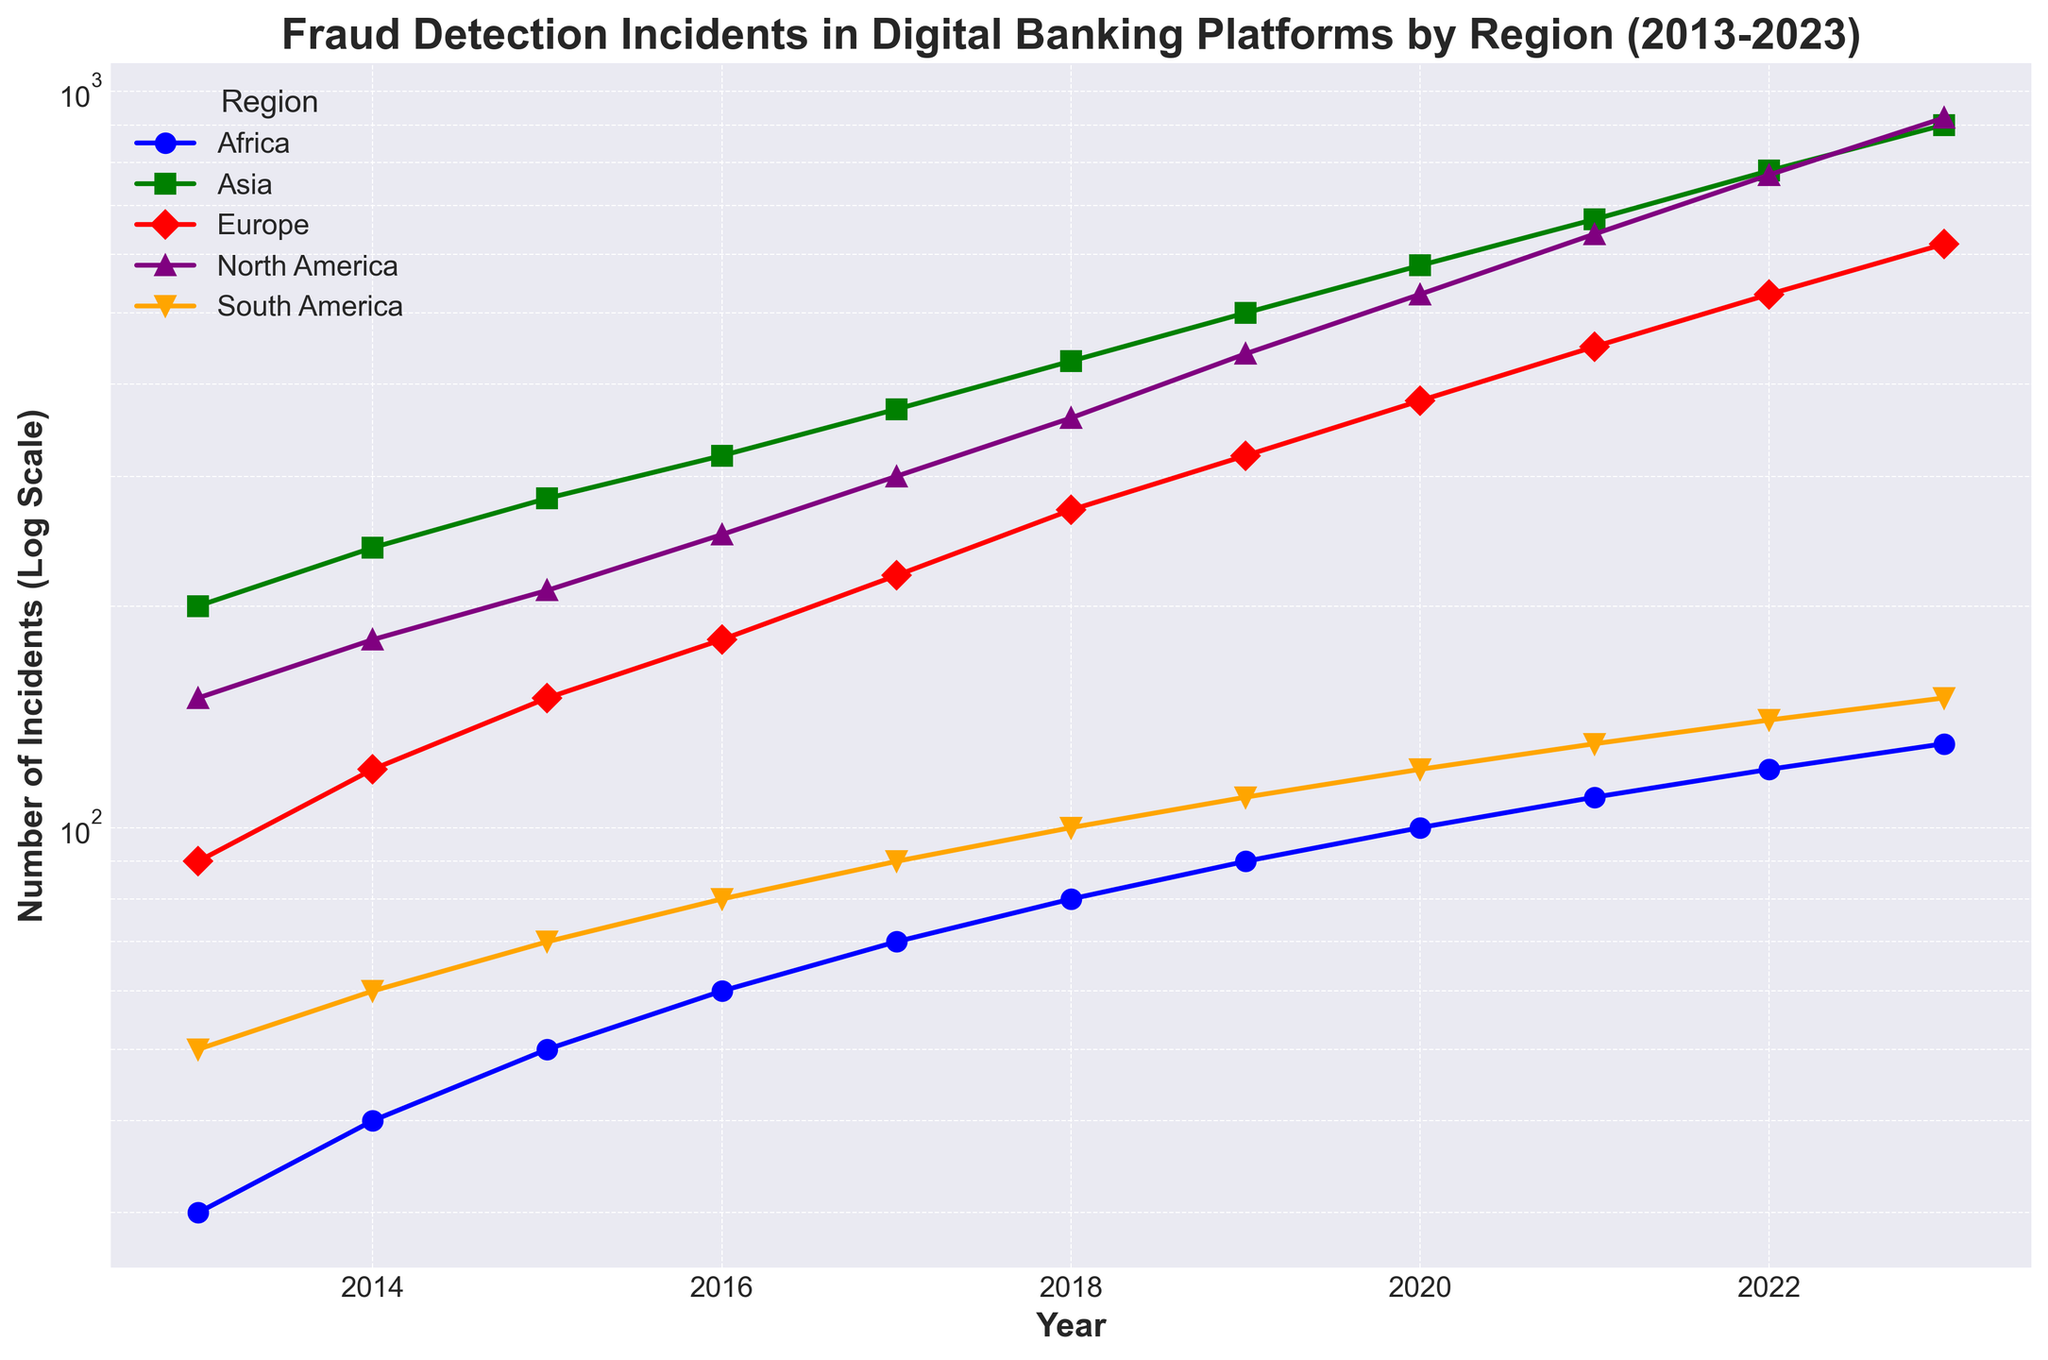Which region reported the highest number of fraud incidents in 2023? Look at the endpoints on the plot for 2023. Find the marker corresponding to each region and compare their values to determine the highest.
Answer: North America Which regions show an upward trend in fraud incidents over the last decade? Observe each region's line plot from 2013 to 2023. Identify which lines show a consistent increase over these years.
Answer: All regions Which year recorded the highest increase in fraud incidents in North America from the previous year? Look at North America's plot points year by year and calculate the difference between consecutive years to identify the biggest jump.
Answer: 2022 By how much did the fraud incidents in Asia increase from 2013 to 2023? Find the endpoints of Asia's plot for 2013 and 2023. Subtract the value of 2013 from 2023 to determine the increase.
Answer: 700 incidents In which year did South America have its first significant increase in fraud incidents? Look at South America's plot from 2013 onwards. Determine the first year when there's a noticeable rise compared to the previous year.
Answer: 2017 Which region had the least number of fraud incidents in 2013? Compare the markers for all regions in 2013 to find the lowest one.
Answer: Africa What is the trend in Europe’s fraud incidents from 2016 to 2019? Observe the plot for Europe from 2016 to 2019. Determine if the line is increasing, decreasing, or stable during these years.
Answer: Increasing Between 2015 and 2020, which region saw the highest percentage growth in fraud incidents? Calculate the percentage growth for each region using the formula \((\text{Incidents in 2020} - \text{Incidents in 2015}) / \text{Incidents in 2015} \times 100\)\% and compare.
Answer: Africa Which two regions showed the closest number of fraud incidents in 2023? Compare the markers of all regions in 2023 and find the two closest in value.
Answer: Europe and Asia 